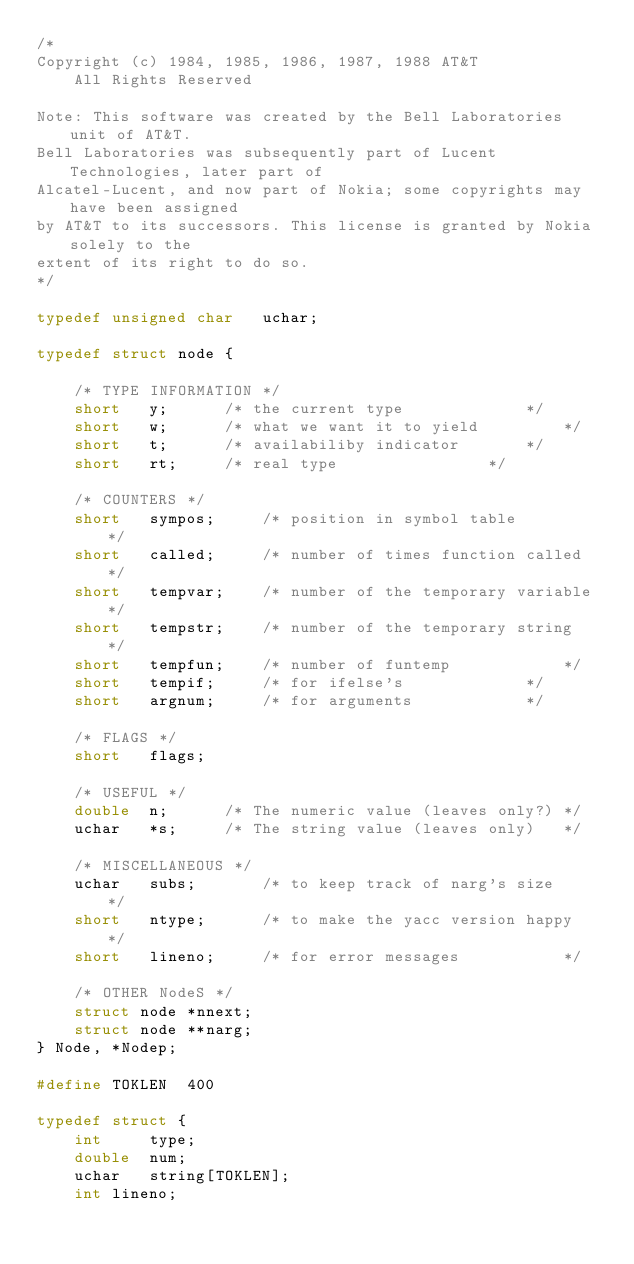<code> <loc_0><loc_0><loc_500><loc_500><_C_>/*
Copyright (c) 1984, 1985, 1986, 1987, 1988 AT&T
	All Rights Reserved

Note: This software was created by the Bell Laboratories unit of AT&T.
Bell Laboratories was subsequently part of Lucent Technologies, later part of
Alcatel-Lucent, and now part of Nokia; some copyrights may have been assigned
by AT&T to its successors. This license is granted by Nokia solely to the
extent of its right to do so.
*/

typedef unsigned char	uchar;

typedef struct node {

	/* TYPE INFORMATION */
	short	y;		/* the current type 			*/
	short	w;		/* what we want it to yield 		*/
	short 	t;		/* availabiliby indicator 		*/
	short	rt;		/* real type 				*/

	/* COUNTERS */
	short	sympos;		/* position in symbol table 		*/
	short	called;		/* number of times function called	*/
	short	tempvar;	/* number of the temporary variable	*/
	short	tempstr;	/* number of the temporary string	*/
	short	tempfun;	/* number of funtemp 			*/
	short	tempif;		/* for ifelse's 			*/
	short	argnum;		/* for arguments			*/

	/* FLAGS */
	short	flags;

	/* USEFUL */
	double	n;		/* The numeric value (leaves only?)	*/
	uchar	*s;		/* The string value (leaves only)	*/

	/* MISCELLANEOUS */
	uchar	subs;		/* to keep track of narg's size 	*/
	short	ntype;		/* to make the yacc version happy 	*/
	short	lineno;		/* for error messages			*/

	/* OTHER NodeS */
	struct node	*nnext;
	struct node	**narg;
} Node, *Nodep;

#define TOKLEN	400

typedef struct {
	int 	type;
	double 	num;
	uchar 	string[TOKLEN];
	int	lineno;</code> 